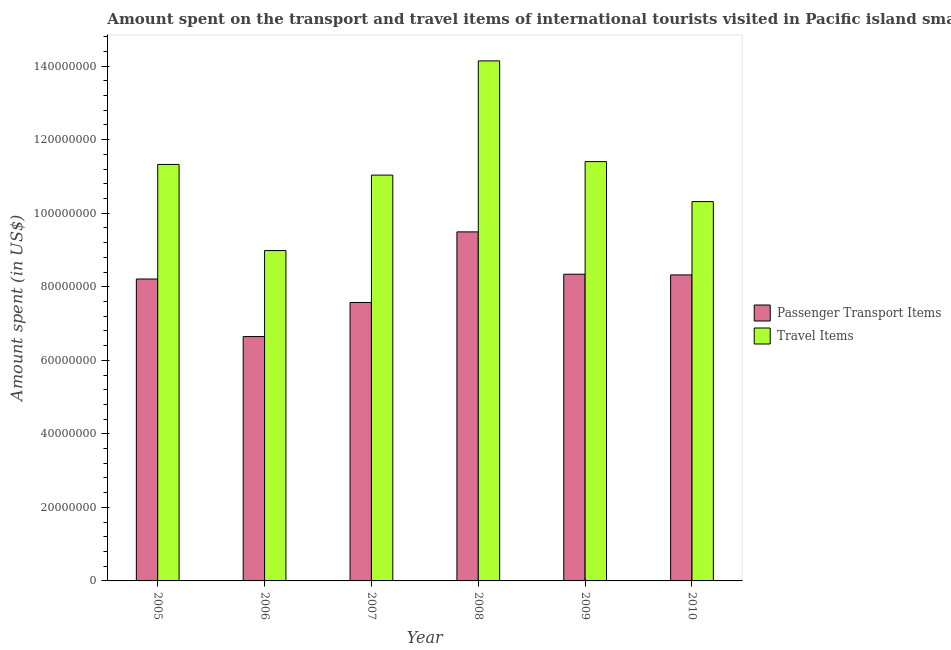How many different coloured bars are there?
Offer a very short reply. 2. How many groups of bars are there?
Ensure brevity in your answer.  6. Are the number of bars on each tick of the X-axis equal?
Make the answer very short. Yes. How many bars are there on the 2nd tick from the right?
Make the answer very short. 2. What is the label of the 2nd group of bars from the left?
Your response must be concise. 2006. In how many cases, is the number of bars for a given year not equal to the number of legend labels?
Offer a very short reply. 0. What is the amount spent on passenger transport items in 2005?
Provide a short and direct response. 8.21e+07. Across all years, what is the maximum amount spent on passenger transport items?
Your response must be concise. 9.49e+07. Across all years, what is the minimum amount spent on passenger transport items?
Keep it short and to the point. 6.65e+07. In which year was the amount spent on passenger transport items maximum?
Offer a very short reply. 2008. In which year was the amount spent in travel items minimum?
Your response must be concise. 2006. What is the total amount spent in travel items in the graph?
Your answer should be compact. 6.72e+08. What is the difference between the amount spent on passenger transport items in 2007 and that in 2008?
Ensure brevity in your answer.  -1.92e+07. What is the difference between the amount spent in travel items in 2005 and the amount spent on passenger transport items in 2010?
Make the answer very short. 1.01e+07. What is the average amount spent in travel items per year?
Ensure brevity in your answer.  1.12e+08. What is the ratio of the amount spent in travel items in 2008 to that in 2009?
Your answer should be very brief. 1.24. Is the amount spent on passenger transport items in 2006 less than that in 2007?
Your response must be concise. Yes. Is the difference between the amount spent in travel items in 2006 and 2009 greater than the difference between the amount spent on passenger transport items in 2006 and 2009?
Your response must be concise. No. What is the difference between the highest and the second highest amount spent on passenger transport items?
Make the answer very short. 1.15e+07. What is the difference between the highest and the lowest amount spent on passenger transport items?
Your answer should be compact. 2.85e+07. In how many years, is the amount spent on passenger transport items greater than the average amount spent on passenger transport items taken over all years?
Provide a succinct answer. 4. What does the 2nd bar from the left in 2006 represents?
Keep it short and to the point. Travel Items. What does the 1st bar from the right in 2006 represents?
Offer a terse response. Travel Items. Are all the bars in the graph horizontal?
Your answer should be very brief. No. What is the difference between two consecutive major ticks on the Y-axis?
Offer a very short reply. 2.00e+07. Are the values on the major ticks of Y-axis written in scientific E-notation?
Your answer should be very brief. No. Does the graph contain any zero values?
Provide a succinct answer. No. Where does the legend appear in the graph?
Your answer should be compact. Center right. How many legend labels are there?
Offer a terse response. 2. How are the legend labels stacked?
Provide a short and direct response. Vertical. What is the title of the graph?
Give a very brief answer. Amount spent on the transport and travel items of international tourists visited in Pacific island small states. Does "Highest 10% of population" appear as one of the legend labels in the graph?
Ensure brevity in your answer.  No. What is the label or title of the X-axis?
Provide a short and direct response. Year. What is the label or title of the Y-axis?
Ensure brevity in your answer.  Amount spent (in US$). What is the Amount spent (in US$) of Passenger Transport Items in 2005?
Offer a very short reply. 8.21e+07. What is the Amount spent (in US$) of Travel Items in 2005?
Your answer should be very brief. 1.13e+08. What is the Amount spent (in US$) in Passenger Transport Items in 2006?
Ensure brevity in your answer.  6.65e+07. What is the Amount spent (in US$) of Travel Items in 2006?
Make the answer very short. 8.98e+07. What is the Amount spent (in US$) in Passenger Transport Items in 2007?
Your response must be concise. 7.57e+07. What is the Amount spent (in US$) in Travel Items in 2007?
Provide a succinct answer. 1.10e+08. What is the Amount spent (in US$) in Passenger Transport Items in 2008?
Give a very brief answer. 9.49e+07. What is the Amount spent (in US$) of Travel Items in 2008?
Keep it short and to the point. 1.41e+08. What is the Amount spent (in US$) of Passenger Transport Items in 2009?
Your response must be concise. 8.34e+07. What is the Amount spent (in US$) of Travel Items in 2009?
Your response must be concise. 1.14e+08. What is the Amount spent (in US$) in Passenger Transport Items in 2010?
Keep it short and to the point. 8.32e+07. What is the Amount spent (in US$) in Travel Items in 2010?
Provide a succinct answer. 1.03e+08. Across all years, what is the maximum Amount spent (in US$) in Passenger Transport Items?
Make the answer very short. 9.49e+07. Across all years, what is the maximum Amount spent (in US$) in Travel Items?
Provide a succinct answer. 1.41e+08. Across all years, what is the minimum Amount spent (in US$) of Passenger Transport Items?
Your answer should be compact. 6.65e+07. Across all years, what is the minimum Amount spent (in US$) of Travel Items?
Provide a short and direct response. 8.98e+07. What is the total Amount spent (in US$) in Passenger Transport Items in the graph?
Give a very brief answer. 4.86e+08. What is the total Amount spent (in US$) in Travel Items in the graph?
Your answer should be very brief. 6.72e+08. What is the difference between the Amount spent (in US$) in Passenger Transport Items in 2005 and that in 2006?
Offer a terse response. 1.57e+07. What is the difference between the Amount spent (in US$) in Travel Items in 2005 and that in 2006?
Your answer should be compact. 2.34e+07. What is the difference between the Amount spent (in US$) in Passenger Transport Items in 2005 and that in 2007?
Your response must be concise. 6.38e+06. What is the difference between the Amount spent (in US$) of Travel Items in 2005 and that in 2007?
Your response must be concise. 2.91e+06. What is the difference between the Amount spent (in US$) of Passenger Transport Items in 2005 and that in 2008?
Offer a terse response. -1.28e+07. What is the difference between the Amount spent (in US$) of Travel Items in 2005 and that in 2008?
Offer a very short reply. -2.82e+07. What is the difference between the Amount spent (in US$) of Passenger Transport Items in 2005 and that in 2009?
Your answer should be very brief. -1.30e+06. What is the difference between the Amount spent (in US$) of Travel Items in 2005 and that in 2009?
Offer a very short reply. -7.65e+05. What is the difference between the Amount spent (in US$) in Passenger Transport Items in 2005 and that in 2010?
Ensure brevity in your answer.  -1.11e+06. What is the difference between the Amount spent (in US$) in Travel Items in 2005 and that in 2010?
Provide a succinct answer. 1.01e+07. What is the difference between the Amount spent (in US$) of Passenger Transport Items in 2006 and that in 2007?
Offer a very short reply. -9.27e+06. What is the difference between the Amount spent (in US$) in Travel Items in 2006 and that in 2007?
Ensure brevity in your answer.  -2.05e+07. What is the difference between the Amount spent (in US$) in Passenger Transport Items in 2006 and that in 2008?
Keep it short and to the point. -2.85e+07. What is the difference between the Amount spent (in US$) in Travel Items in 2006 and that in 2008?
Offer a very short reply. -5.16e+07. What is the difference between the Amount spent (in US$) of Passenger Transport Items in 2006 and that in 2009?
Make the answer very short. -1.70e+07. What is the difference between the Amount spent (in US$) of Travel Items in 2006 and that in 2009?
Offer a terse response. -2.42e+07. What is the difference between the Amount spent (in US$) in Passenger Transport Items in 2006 and that in 2010?
Make the answer very short. -1.68e+07. What is the difference between the Amount spent (in US$) of Travel Items in 2006 and that in 2010?
Keep it short and to the point. -1.33e+07. What is the difference between the Amount spent (in US$) in Passenger Transport Items in 2007 and that in 2008?
Your answer should be very brief. -1.92e+07. What is the difference between the Amount spent (in US$) of Travel Items in 2007 and that in 2008?
Your answer should be compact. -3.11e+07. What is the difference between the Amount spent (in US$) of Passenger Transport Items in 2007 and that in 2009?
Keep it short and to the point. -7.69e+06. What is the difference between the Amount spent (in US$) of Travel Items in 2007 and that in 2009?
Ensure brevity in your answer.  -3.67e+06. What is the difference between the Amount spent (in US$) in Passenger Transport Items in 2007 and that in 2010?
Provide a short and direct response. -7.50e+06. What is the difference between the Amount spent (in US$) in Travel Items in 2007 and that in 2010?
Ensure brevity in your answer.  7.20e+06. What is the difference between the Amount spent (in US$) in Passenger Transport Items in 2008 and that in 2009?
Your answer should be compact. 1.15e+07. What is the difference between the Amount spent (in US$) in Travel Items in 2008 and that in 2009?
Offer a very short reply. 2.74e+07. What is the difference between the Amount spent (in US$) in Passenger Transport Items in 2008 and that in 2010?
Your answer should be very brief. 1.17e+07. What is the difference between the Amount spent (in US$) of Travel Items in 2008 and that in 2010?
Keep it short and to the point. 3.83e+07. What is the difference between the Amount spent (in US$) of Passenger Transport Items in 2009 and that in 2010?
Provide a succinct answer. 1.92e+05. What is the difference between the Amount spent (in US$) of Travel Items in 2009 and that in 2010?
Ensure brevity in your answer.  1.09e+07. What is the difference between the Amount spent (in US$) of Passenger Transport Items in 2005 and the Amount spent (in US$) of Travel Items in 2006?
Your answer should be very brief. -7.73e+06. What is the difference between the Amount spent (in US$) of Passenger Transport Items in 2005 and the Amount spent (in US$) of Travel Items in 2007?
Provide a succinct answer. -2.83e+07. What is the difference between the Amount spent (in US$) of Passenger Transport Items in 2005 and the Amount spent (in US$) of Travel Items in 2008?
Offer a terse response. -5.93e+07. What is the difference between the Amount spent (in US$) of Passenger Transport Items in 2005 and the Amount spent (in US$) of Travel Items in 2009?
Make the answer very short. -3.19e+07. What is the difference between the Amount spent (in US$) of Passenger Transport Items in 2005 and the Amount spent (in US$) of Travel Items in 2010?
Provide a succinct answer. -2.11e+07. What is the difference between the Amount spent (in US$) of Passenger Transport Items in 2006 and the Amount spent (in US$) of Travel Items in 2007?
Ensure brevity in your answer.  -4.39e+07. What is the difference between the Amount spent (in US$) of Passenger Transport Items in 2006 and the Amount spent (in US$) of Travel Items in 2008?
Your response must be concise. -7.50e+07. What is the difference between the Amount spent (in US$) in Passenger Transport Items in 2006 and the Amount spent (in US$) in Travel Items in 2009?
Ensure brevity in your answer.  -4.76e+07. What is the difference between the Amount spent (in US$) of Passenger Transport Items in 2006 and the Amount spent (in US$) of Travel Items in 2010?
Your answer should be very brief. -3.67e+07. What is the difference between the Amount spent (in US$) in Passenger Transport Items in 2007 and the Amount spent (in US$) in Travel Items in 2008?
Your response must be concise. -6.57e+07. What is the difference between the Amount spent (in US$) in Passenger Transport Items in 2007 and the Amount spent (in US$) in Travel Items in 2009?
Keep it short and to the point. -3.83e+07. What is the difference between the Amount spent (in US$) in Passenger Transport Items in 2007 and the Amount spent (in US$) in Travel Items in 2010?
Offer a terse response. -2.74e+07. What is the difference between the Amount spent (in US$) of Passenger Transport Items in 2008 and the Amount spent (in US$) of Travel Items in 2009?
Ensure brevity in your answer.  -1.91e+07. What is the difference between the Amount spent (in US$) of Passenger Transport Items in 2008 and the Amount spent (in US$) of Travel Items in 2010?
Offer a very short reply. -8.24e+06. What is the difference between the Amount spent (in US$) in Passenger Transport Items in 2009 and the Amount spent (in US$) in Travel Items in 2010?
Offer a very short reply. -1.97e+07. What is the average Amount spent (in US$) of Passenger Transport Items per year?
Your answer should be compact. 8.10e+07. What is the average Amount spent (in US$) of Travel Items per year?
Your response must be concise. 1.12e+08. In the year 2005, what is the difference between the Amount spent (in US$) in Passenger Transport Items and Amount spent (in US$) in Travel Items?
Your answer should be compact. -3.12e+07. In the year 2006, what is the difference between the Amount spent (in US$) in Passenger Transport Items and Amount spent (in US$) in Travel Items?
Give a very brief answer. -2.34e+07. In the year 2007, what is the difference between the Amount spent (in US$) of Passenger Transport Items and Amount spent (in US$) of Travel Items?
Offer a very short reply. -3.46e+07. In the year 2008, what is the difference between the Amount spent (in US$) of Passenger Transport Items and Amount spent (in US$) of Travel Items?
Provide a succinct answer. -4.65e+07. In the year 2009, what is the difference between the Amount spent (in US$) in Passenger Transport Items and Amount spent (in US$) in Travel Items?
Keep it short and to the point. -3.06e+07. In the year 2010, what is the difference between the Amount spent (in US$) in Passenger Transport Items and Amount spent (in US$) in Travel Items?
Provide a short and direct response. -1.99e+07. What is the ratio of the Amount spent (in US$) of Passenger Transport Items in 2005 to that in 2006?
Your answer should be compact. 1.24. What is the ratio of the Amount spent (in US$) in Travel Items in 2005 to that in 2006?
Provide a succinct answer. 1.26. What is the ratio of the Amount spent (in US$) of Passenger Transport Items in 2005 to that in 2007?
Keep it short and to the point. 1.08. What is the ratio of the Amount spent (in US$) in Travel Items in 2005 to that in 2007?
Your answer should be compact. 1.03. What is the ratio of the Amount spent (in US$) of Passenger Transport Items in 2005 to that in 2008?
Ensure brevity in your answer.  0.86. What is the ratio of the Amount spent (in US$) in Travel Items in 2005 to that in 2008?
Keep it short and to the point. 0.8. What is the ratio of the Amount spent (in US$) in Passenger Transport Items in 2005 to that in 2009?
Offer a terse response. 0.98. What is the ratio of the Amount spent (in US$) in Passenger Transport Items in 2005 to that in 2010?
Ensure brevity in your answer.  0.99. What is the ratio of the Amount spent (in US$) in Travel Items in 2005 to that in 2010?
Ensure brevity in your answer.  1.1. What is the ratio of the Amount spent (in US$) in Passenger Transport Items in 2006 to that in 2007?
Your answer should be very brief. 0.88. What is the ratio of the Amount spent (in US$) of Travel Items in 2006 to that in 2007?
Your answer should be very brief. 0.81. What is the ratio of the Amount spent (in US$) of Passenger Transport Items in 2006 to that in 2008?
Offer a very short reply. 0.7. What is the ratio of the Amount spent (in US$) in Travel Items in 2006 to that in 2008?
Provide a succinct answer. 0.64. What is the ratio of the Amount spent (in US$) in Passenger Transport Items in 2006 to that in 2009?
Offer a terse response. 0.8. What is the ratio of the Amount spent (in US$) of Travel Items in 2006 to that in 2009?
Your answer should be compact. 0.79. What is the ratio of the Amount spent (in US$) of Passenger Transport Items in 2006 to that in 2010?
Ensure brevity in your answer.  0.8. What is the ratio of the Amount spent (in US$) in Travel Items in 2006 to that in 2010?
Offer a terse response. 0.87. What is the ratio of the Amount spent (in US$) in Passenger Transport Items in 2007 to that in 2008?
Your answer should be very brief. 0.8. What is the ratio of the Amount spent (in US$) in Travel Items in 2007 to that in 2008?
Keep it short and to the point. 0.78. What is the ratio of the Amount spent (in US$) in Passenger Transport Items in 2007 to that in 2009?
Ensure brevity in your answer.  0.91. What is the ratio of the Amount spent (in US$) in Travel Items in 2007 to that in 2009?
Make the answer very short. 0.97. What is the ratio of the Amount spent (in US$) in Passenger Transport Items in 2007 to that in 2010?
Your response must be concise. 0.91. What is the ratio of the Amount spent (in US$) of Travel Items in 2007 to that in 2010?
Keep it short and to the point. 1.07. What is the ratio of the Amount spent (in US$) of Passenger Transport Items in 2008 to that in 2009?
Provide a short and direct response. 1.14. What is the ratio of the Amount spent (in US$) of Travel Items in 2008 to that in 2009?
Your answer should be very brief. 1.24. What is the ratio of the Amount spent (in US$) of Passenger Transport Items in 2008 to that in 2010?
Your answer should be very brief. 1.14. What is the ratio of the Amount spent (in US$) in Travel Items in 2008 to that in 2010?
Provide a succinct answer. 1.37. What is the ratio of the Amount spent (in US$) in Travel Items in 2009 to that in 2010?
Offer a terse response. 1.11. What is the difference between the highest and the second highest Amount spent (in US$) in Passenger Transport Items?
Make the answer very short. 1.15e+07. What is the difference between the highest and the second highest Amount spent (in US$) of Travel Items?
Your answer should be compact. 2.74e+07. What is the difference between the highest and the lowest Amount spent (in US$) in Passenger Transport Items?
Provide a succinct answer. 2.85e+07. What is the difference between the highest and the lowest Amount spent (in US$) of Travel Items?
Provide a short and direct response. 5.16e+07. 